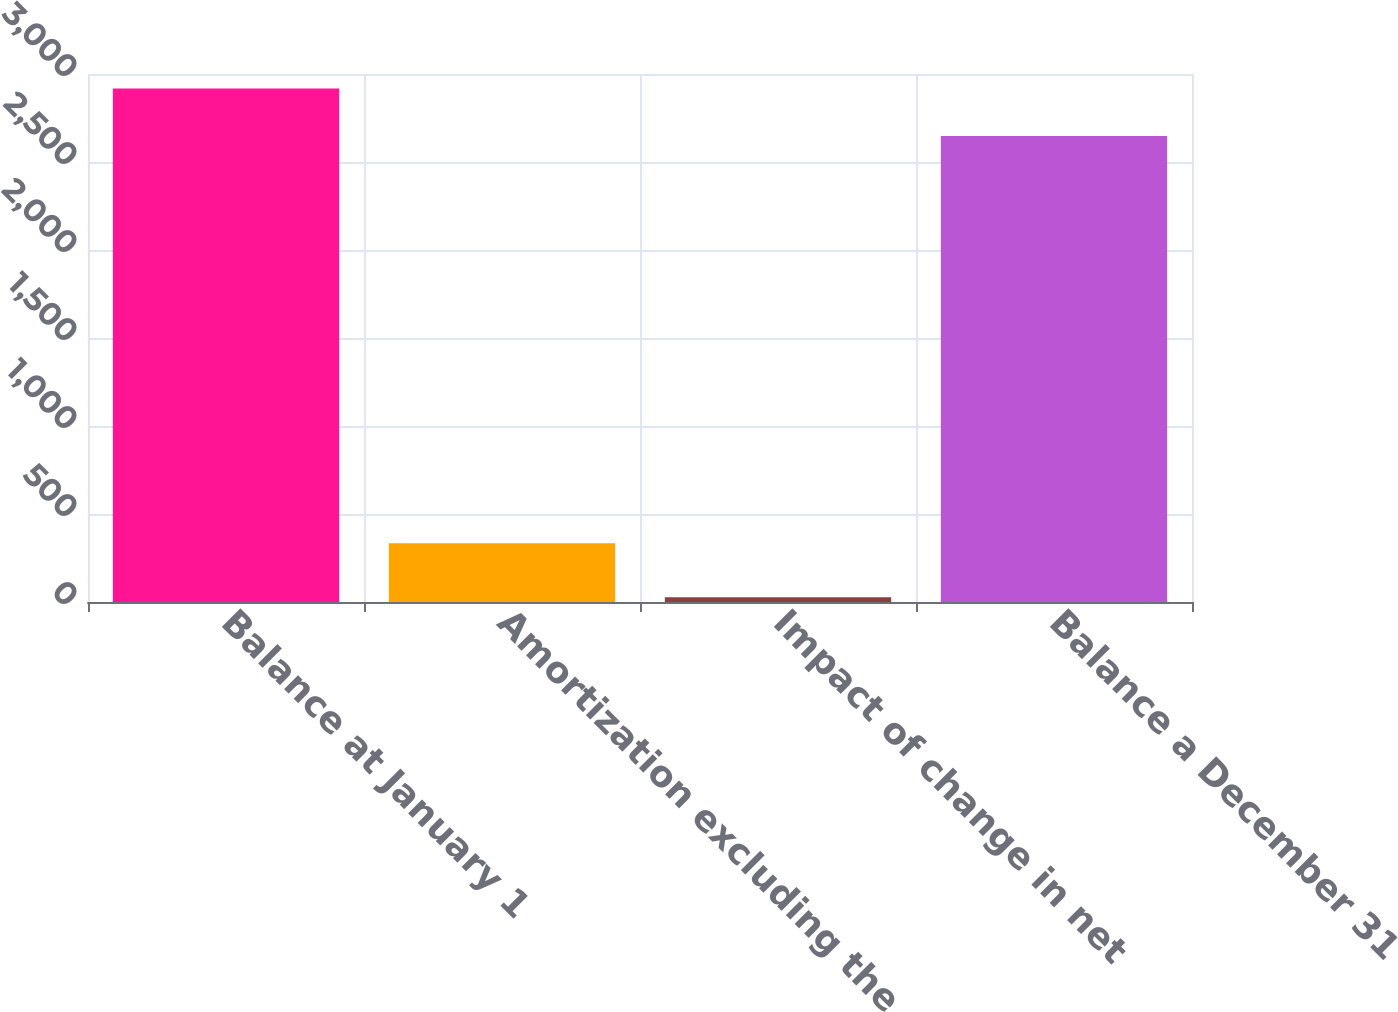Convert chart. <chart><loc_0><loc_0><loc_500><loc_500><bar_chart><fcel>Balance at January 1<fcel>Amortization excluding the<fcel>Impact of change in net<fcel>Balance a December 31<nl><fcel>2918.3<fcel>334<fcel>27<fcel>2648<nl></chart> 